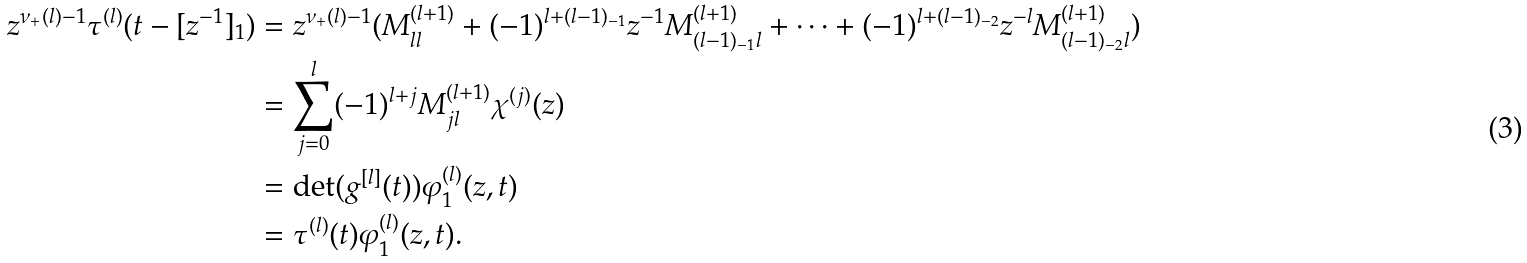Convert formula to latex. <formula><loc_0><loc_0><loc_500><loc_500>z ^ { \nu _ { + } ( l ) - 1 } \tau ^ { ( l ) } ( t - [ z ^ { - 1 } ] _ { 1 } ) & = z ^ { \nu _ { + } ( l ) - 1 } ( M _ { l l } ^ { ( l + 1 ) } + ( - 1 ) ^ { l + ( l - 1 ) _ { - 1 } } z ^ { - 1 } M _ { ( l - 1 ) _ { - 1 } l } ^ { ( l + 1 ) } + \cdots + ( - 1 ) ^ { l + ( l - 1 ) _ { - 2 } } z ^ { - l } M _ { ( l - 1 ) _ { - 2 } l } ^ { ( l + 1 ) } ) \\ & = \sum _ { j = 0 } ^ { l } ( - 1 ) ^ { l + j } M _ { j l } ^ { ( l + 1 ) } \chi ^ { ( j ) } ( z ) \\ & = \det ( g ^ { [ l ] } ( t ) ) \varphi _ { 1 } ^ { ( l ) } ( z , t ) \\ & = \tau ^ { ( l ) } ( t ) \varphi _ { 1 } ^ { ( l ) } ( z , t ) .</formula> 